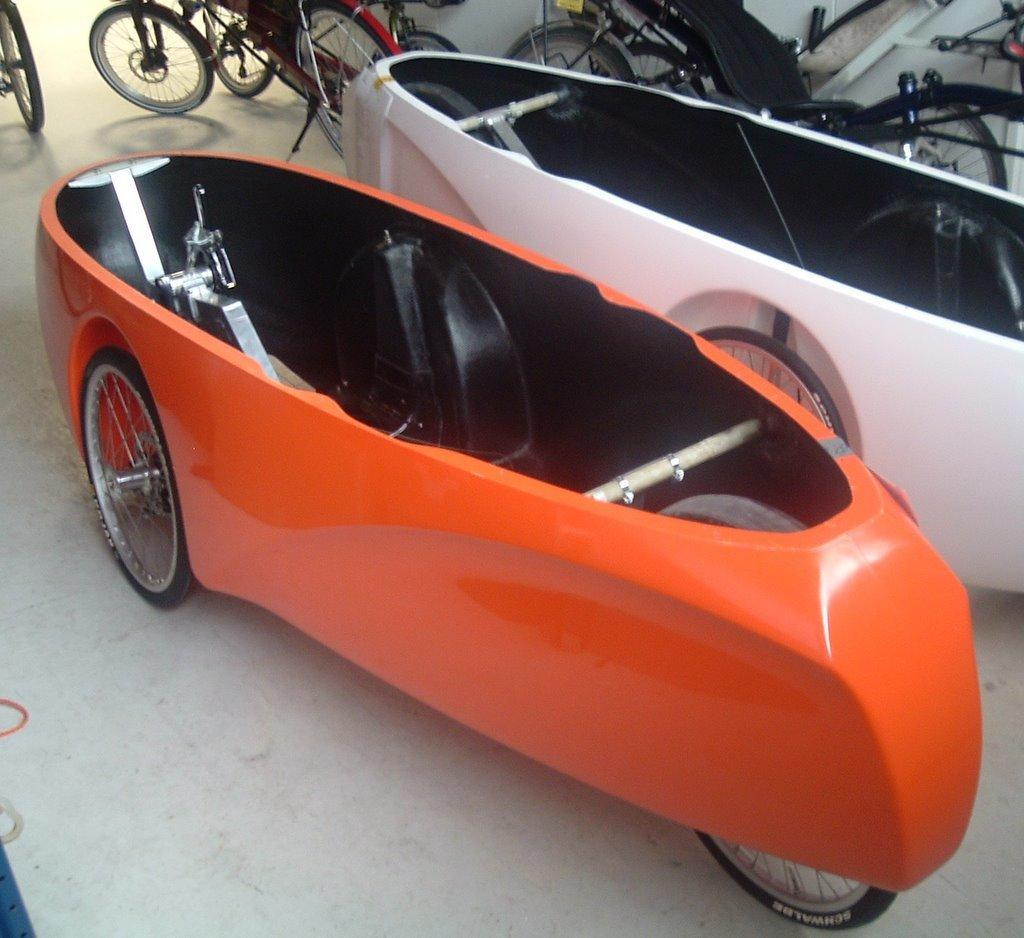What types of transportation are present in the image? There are vehicles and bicycles in the image. What kind of structure can be seen in the image? There is a wall in the image. How many heads of cake can be seen on the bicycles in the image? There are no heads of cake present in the image; it features vehicles, bicycles, and a wall. How many men are visible on the vehicles in the image? There is no information about men or their presence on the vehicles in the image. 